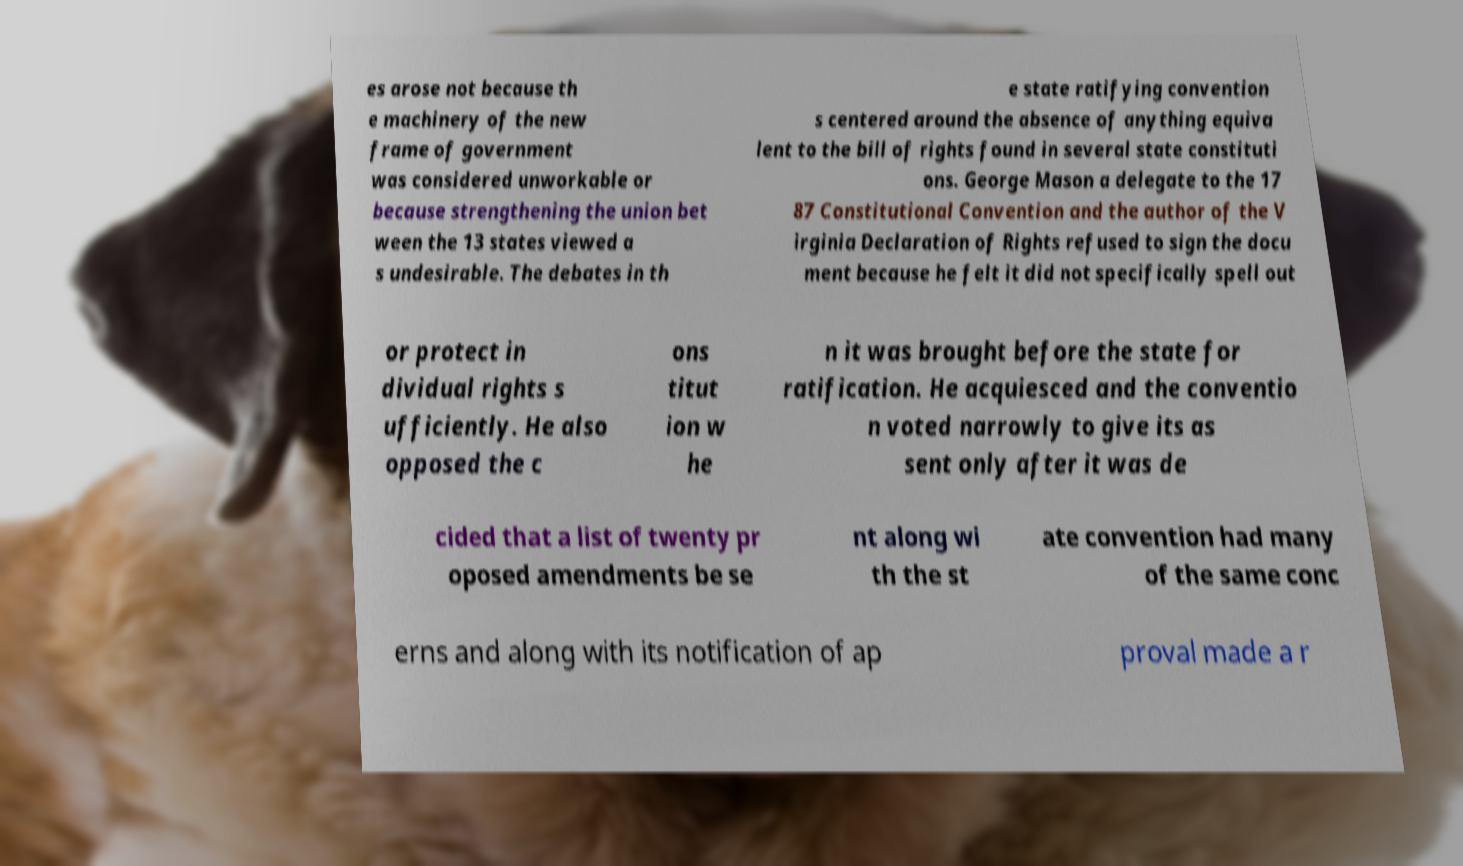Can you read and provide the text displayed in the image?This photo seems to have some interesting text. Can you extract and type it out for me? es arose not because th e machinery of the new frame of government was considered unworkable or because strengthening the union bet ween the 13 states viewed a s undesirable. The debates in th e state ratifying convention s centered around the absence of anything equiva lent to the bill of rights found in several state constituti ons. George Mason a delegate to the 17 87 Constitutional Convention and the author of the V irginia Declaration of Rights refused to sign the docu ment because he felt it did not specifically spell out or protect in dividual rights s ufficiently. He also opposed the c ons titut ion w he n it was brought before the state for ratification. He acquiesced and the conventio n voted narrowly to give its as sent only after it was de cided that a list of twenty pr oposed amendments be se nt along wi th the st ate convention had many of the same conc erns and along with its notification of ap proval made a r 